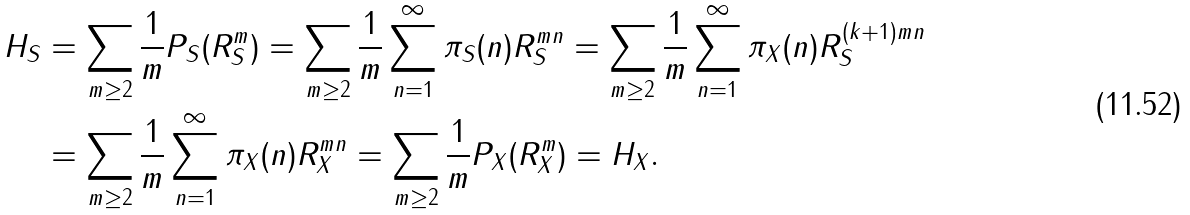<formula> <loc_0><loc_0><loc_500><loc_500>H _ { S } & = \sum _ { m \geq 2 } \frac { 1 } { m } P _ { S } ( R _ { S } ^ { m } ) = \sum _ { m \geq 2 } \frac { 1 } { m } \sum _ { n = 1 } ^ { \infty } \pi _ { S } ( n ) R _ { S } ^ { m n } = \sum _ { m \geq 2 } \frac { 1 } { m } \sum _ { n = 1 } ^ { \infty } \pi _ { X } ( n ) R _ { S } ^ { ( k + 1 ) m n } \\ & = \sum _ { m \geq 2 } \frac { 1 } { m } \sum _ { n = 1 } ^ { \infty } \pi _ { X } ( n ) R _ { X } ^ { m n } = \sum _ { m \geq 2 } \frac { 1 } { m } P _ { X } ( R _ { X } ^ { m } ) = H _ { X } .</formula> 